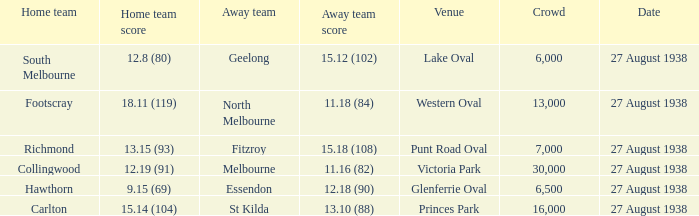What is the average crowd attendance for Collingwood? 30000.0. 